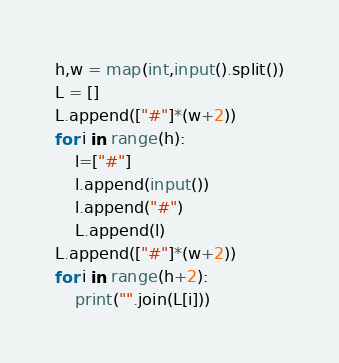Convert code to text. <code><loc_0><loc_0><loc_500><loc_500><_Python_>h,w = map(int,input().split())
L = []
L.append(["#"]*(w+2))
for i in range(h):
    l=["#"]
    l.append(input())
    l.append("#")
    L.append(l)
L.append(["#"]*(w+2))
for i in range(h+2):
    print("".join(L[i]))</code> 